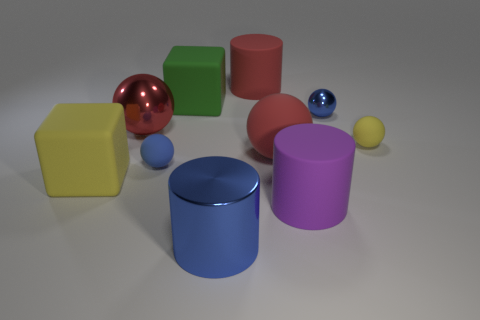Is the number of metallic objects on the right side of the tiny metallic sphere less than the number of shiny things behind the yellow rubber cube?
Provide a short and direct response. Yes. What number of yellow objects are either shiny balls or metallic cylinders?
Give a very brief answer. 0. Are there the same number of large yellow matte cubes that are in front of the large red cylinder and tiny yellow rubber spheres?
Keep it short and to the point. Yes. How many things are small yellow matte things or rubber things that are on the left side of the tiny shiny ball?
Offer a terse response. 7. Do the metallic cylinder and the large matte sphere have the same color?
Ensure brevity in your answer.  No. Are there any big objects that have the same material as the green cube?
Make the answer very short. Yes. There is a big matte thing that is the same shape as the tiny yellow thing; what is its color?
Offer a terse response. Red. Is the material of the purple cylinder the same as the small blue ball that is to the left of the red matte ball?
Your answer should be very brief. Yes. There is a blue metallic object that is in front of the yellow rubber cube on the left side of the small blue metal sphere; what shape is it?
Ensure brevity in your answer.  Cylinder. There is a object that is in front of the purple cylinder; does it have the same size as the big green cube?
Offer a terse response. Yes. 